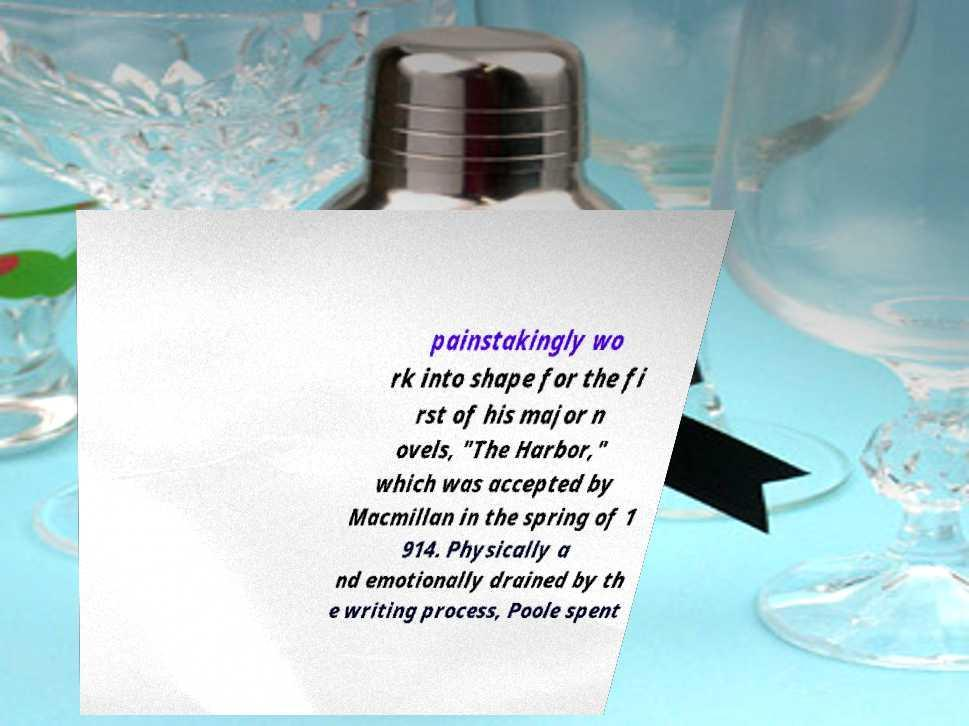Can you read and provide the text displayed in the image?This photo seems to have some interesting text. Can you extract and type it out for me? painstakingly wo rk into shape for the fi rst of his major n ovels, "The Harbor," which was accepted by Macmillan in the spring of 1 914. Physically a nd emotionally drained by th e writing process, Poole spent 